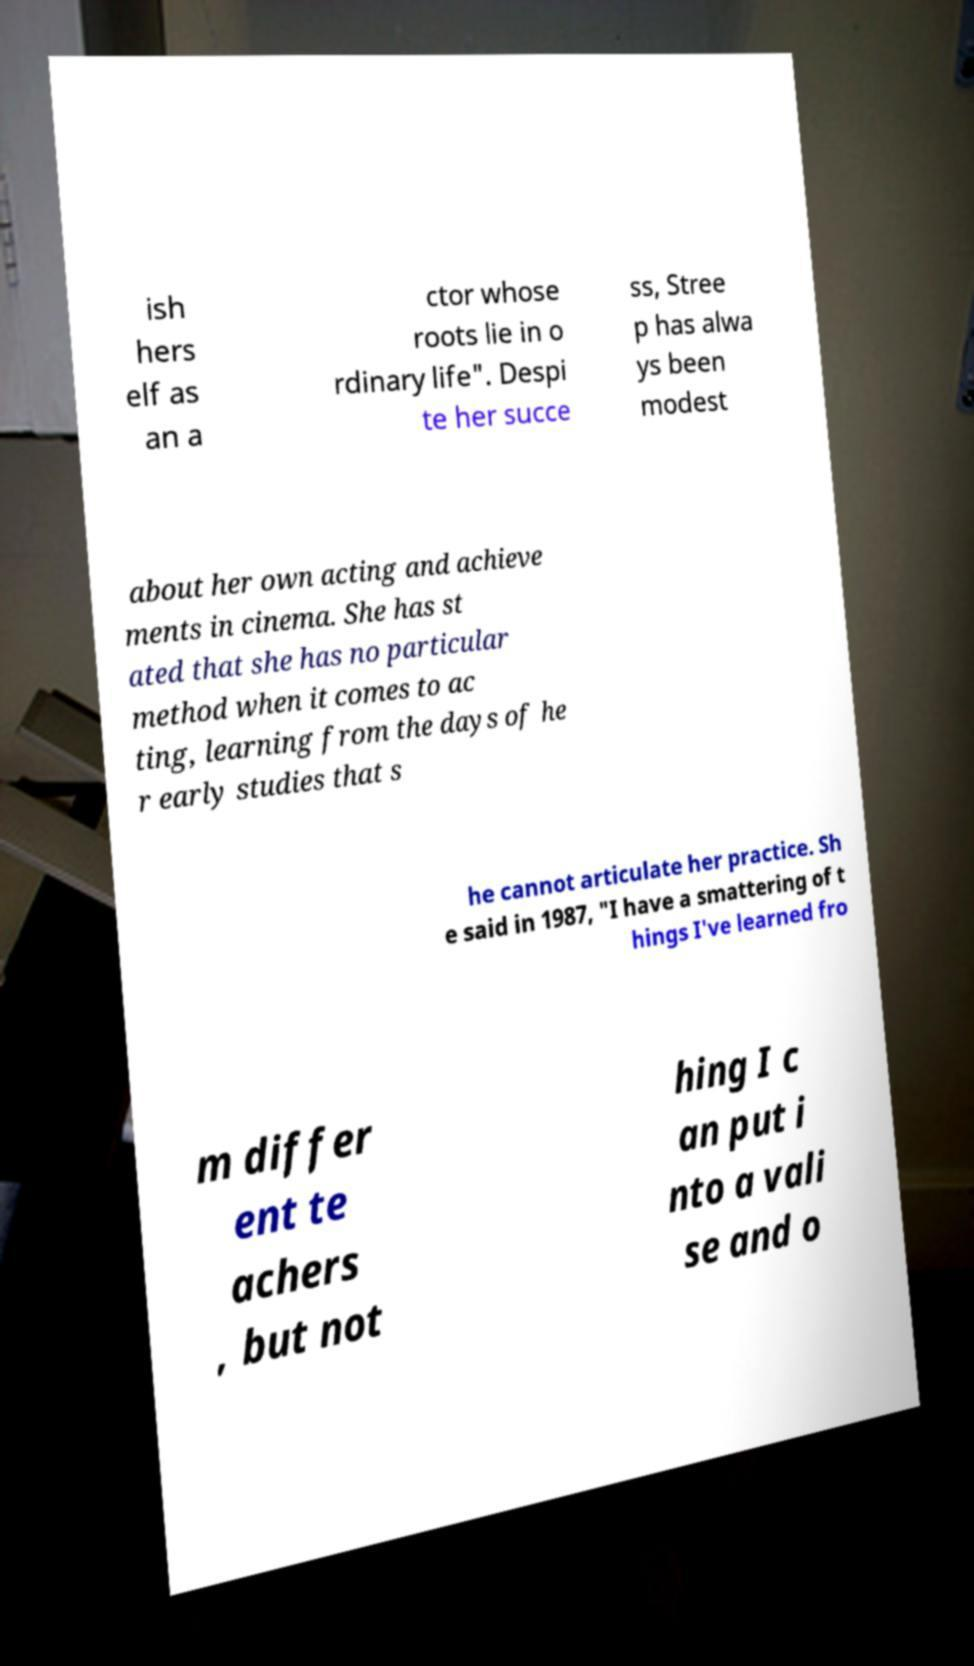Can you accurately transcribe the text from the provided image for me? ish hers elf as an a ctor whose roots lie in o rdinary life". Despi te her succe ss, Stree p has alwa ys been modest about her own acting and achieve ments in cinema. She has st ated that she has no particular method when it comes to ac ting, learning from the days of he r early studies that s he cannot articulate her practice. Sh e said in 1987, "I have a smattering of t hings I've learned fro m differ ent te achers , but not hing I c an put i nto a vali se and o 